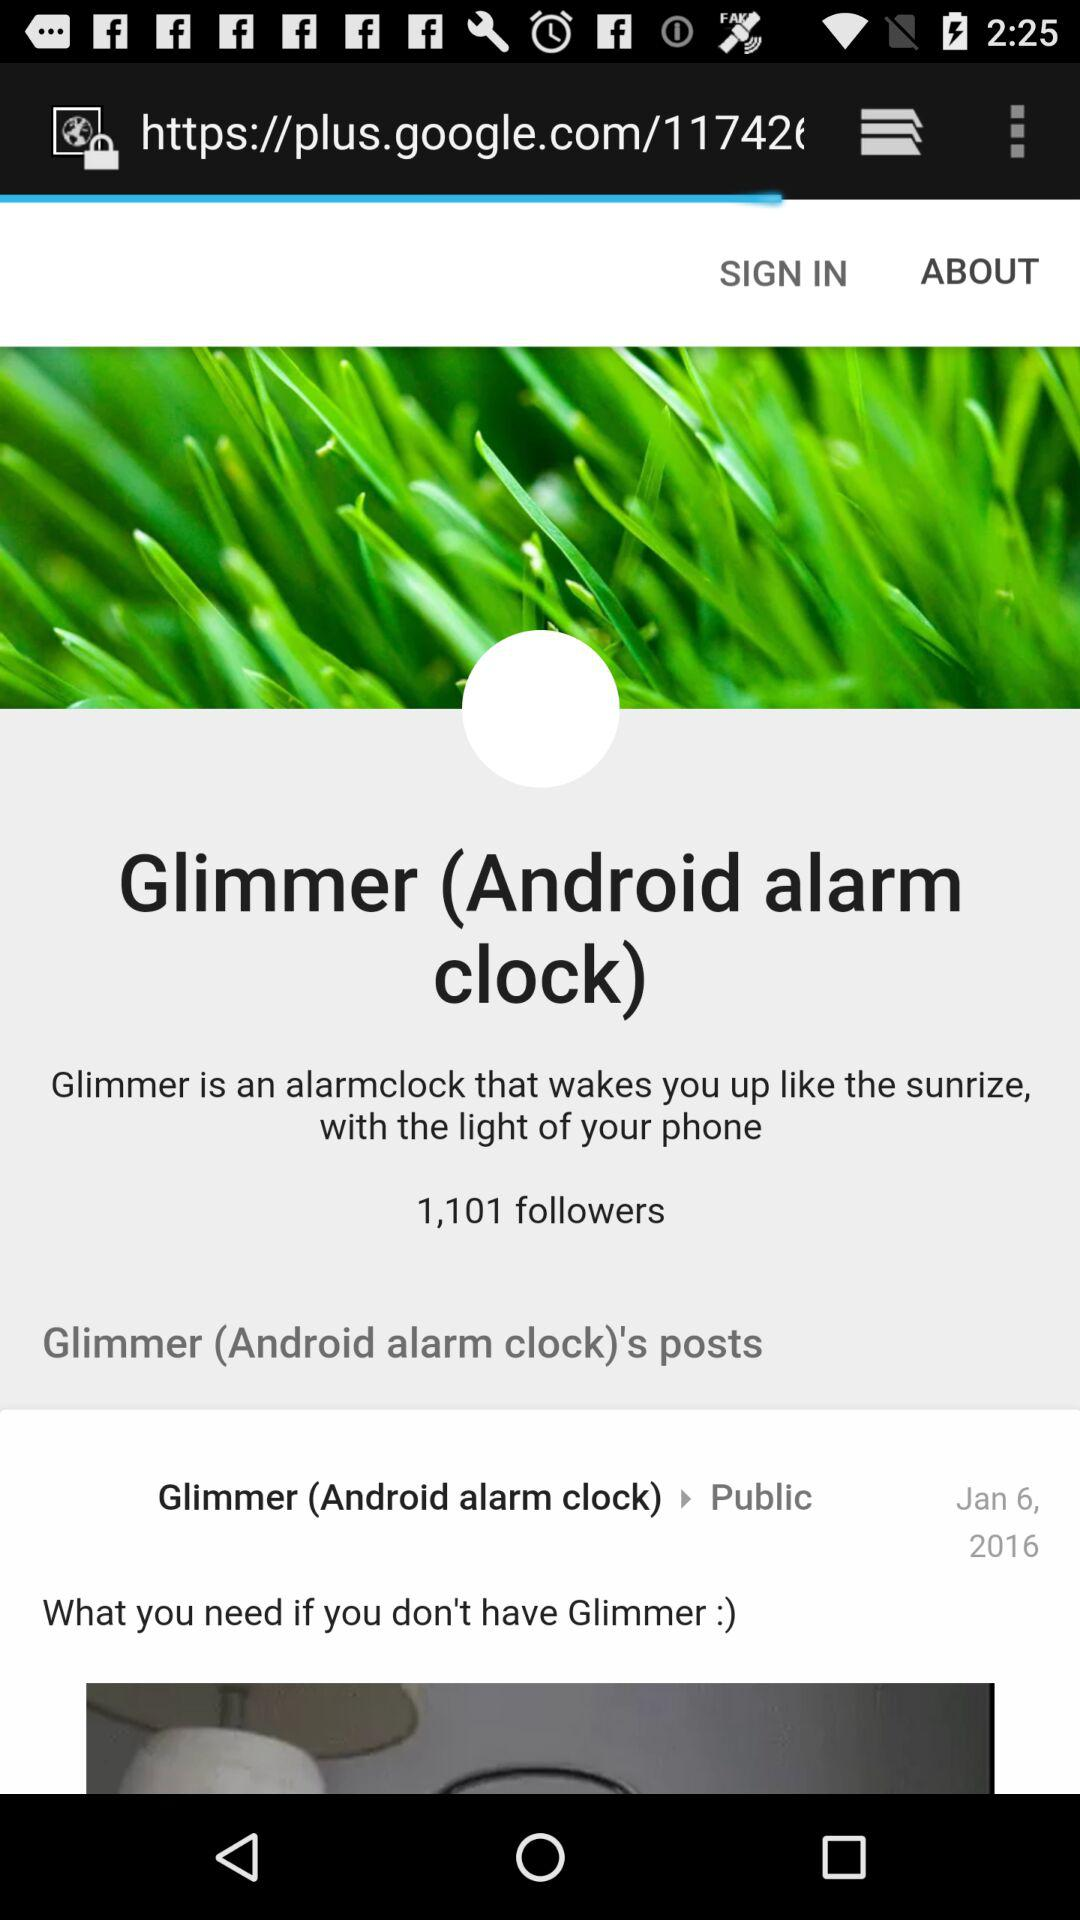What is Glimmer? The Glimmer is an alarmclock that wakes you up like the sunrize, with the light of your phone. 